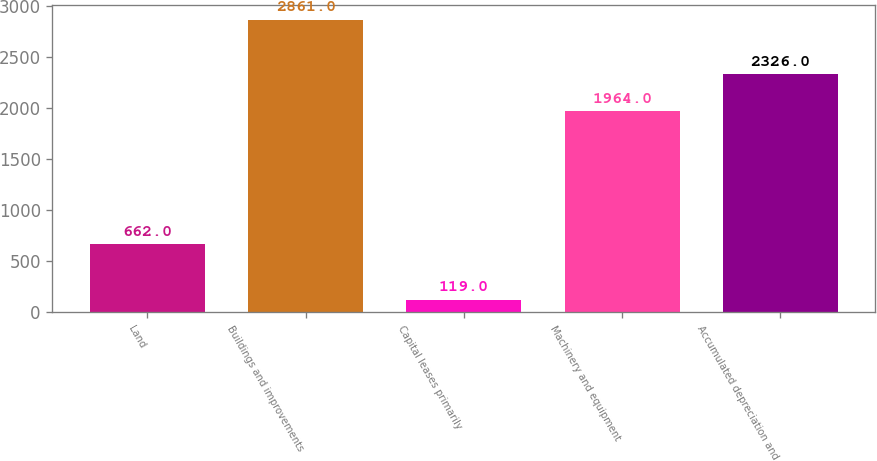<chart> <loc_0><loc_0><loc_500><loc_500><bar_chart><fcel>Land<fcel>Buildings and improvements<fcel>Capital leases primarily<fcel>Machinery and equipment<fcel>Accumulated depreciation and<nl><fcel>662<fcel>2861<fcel>119<fcel>1964<fcel>2326<nl></chart> 